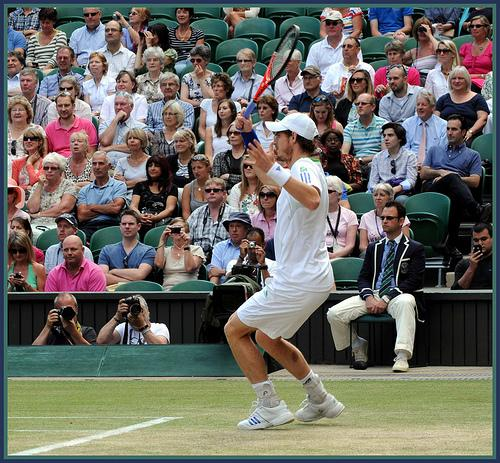Count the number of photographers taking pictures of the tennis match. There are three photographers snapping pictures of the event. Give a brief account of the people actively watching the tennis match. There is a man in a pink shirt, woman using her phone, bald man in a pink shirt, a man wearing black rimed sunglasses, and a woman with binoculars, all attentively observing the game. How would you narrate the central activity shown in the image? A tennis player, dressed in white, is poised to swing his racquet as spectators watch and photographers take photos of the heated match. Analyze the seating arrangements and any standout elements of the tennis match venue. Some spectators are seated in the stands, with a notable empty green chair amidst the crowd, while others stand close to the court as photographers and officials. Describe the fashion choices for those in attendance at the tennis match. Spectators have chosen various outfits such as pink shirts, green tops, white shirts, and blue sport coats, exhibiting a blend of personal styles. Share your observation about the tennis player's physical appearance and playing equipment. The tennis player, dressed in white, has a birthmark on his leg and is wielding a red, blue, and black tennis racquet. Describe the appearance of the tennis player's sneakers. The tennis player's sneakers are white with blue stripes and a blue brand symbol. Identify the camera positioning and activity of the photographers during the tennis match. Photographers are capturing the heated moments of the game with their cameras, positioned nearby the tennis court. Examine the tennis player's outfit and attire. What does he wear? The tennis player dons a white cap, white wrist band, white shirt, white shorts, and white sneakers with blue stripes. Discuss the appearance of the officials and the photographer at the event. The official wears a dark blue sport coat, a tie with green diagonal stripes, black-rimmed sunglasses, and white pants, while the photographers are clad in white and black shirts. 